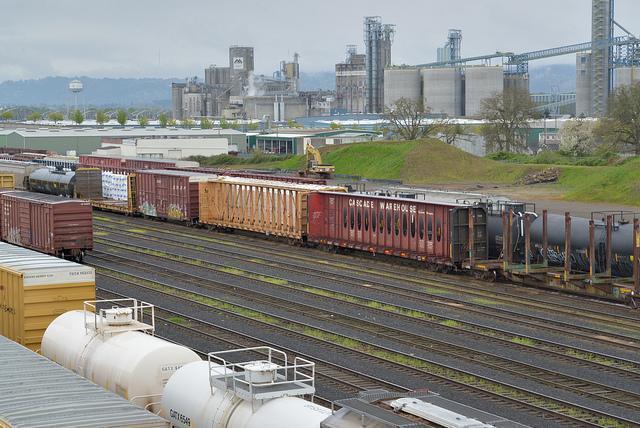What vehicles are here?
Make your selection from the four choices given to correctly answer the question.
Options: Trucks, airplanes, trains, horses. Trains. 